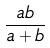<formula> <loc_0><loc_0><loc_500><loc_500>\frac { a b } { a + b }</formula> 